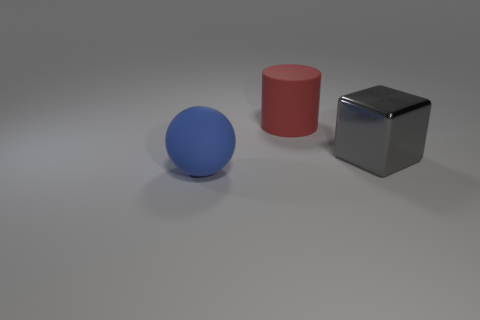Add 3 large red cylinders. How many objects exist? 6 Subtract all cubes. How many objects are left? 2 Subtract all tiny green blocks. Subtract all big rubber cylinders. How many objects are left? 2 Add 3 gray blocks. How many gray blocks are left? 4 Add 1 large gray blocks. How many large gray blocks exist? 2 Subtract 0 brown cylinders. How many objects are left? 3 